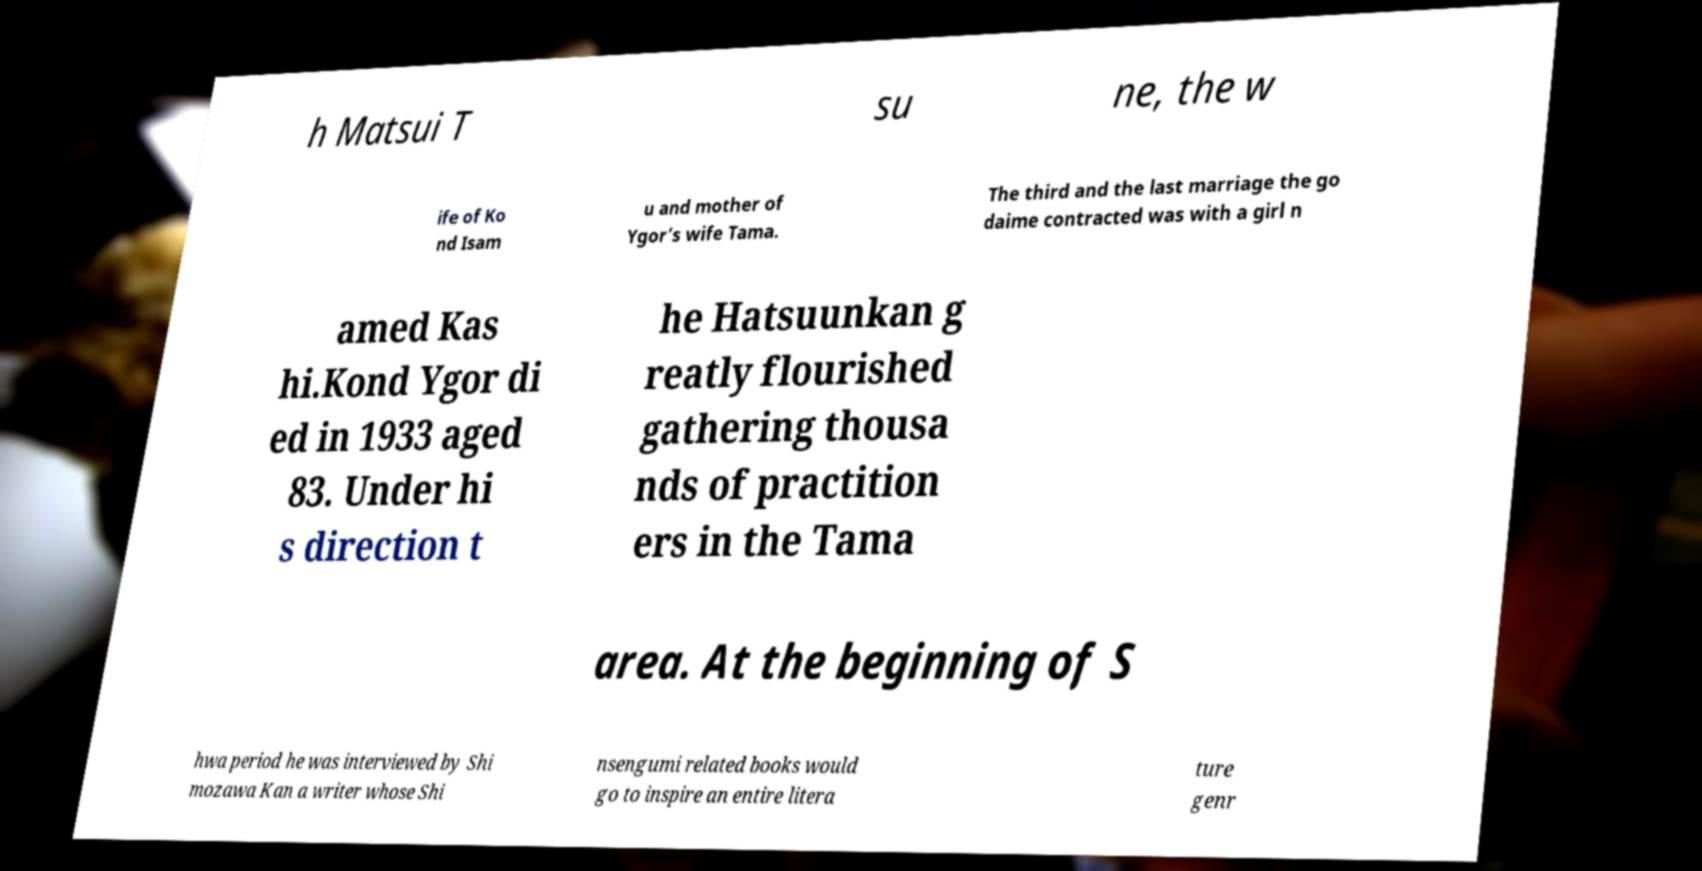Could you assist in decoding the text presented in this image and type it out clearly? h Matsui T su ne, the w ife of Ko nd Isam u and mother of Ygor’s wife Tama. The third and the last marriage the go daime contracted was with a girl n amed Kas hi.Kond Ygor di ed in 1933 aged 83. Under hi s direction t he Hatsuunkan g reatly flourished gathering thousa nds of practition ers in the Tama area. At the beginning of S hwa period he was interviewed by Shi mozawa Kan a writer whose Shi nsengumi related books would go to inspire an entire litera ture genr 